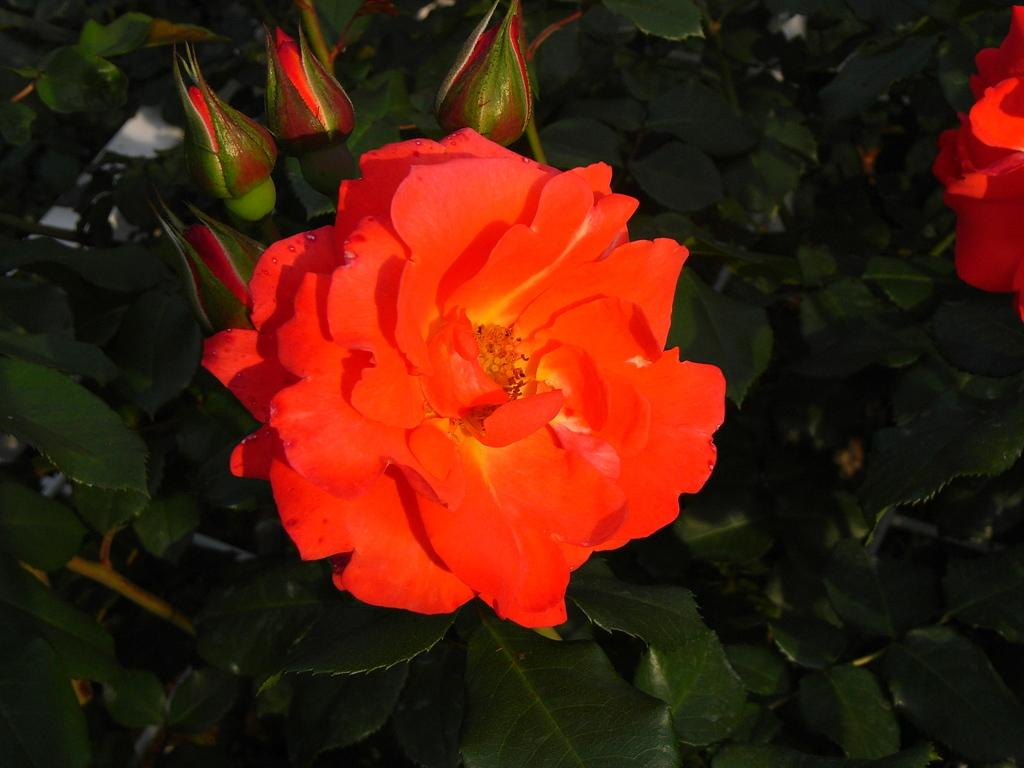What type of living organisms are present in the image? There is a group of plants in the image. Can you identify any specific flowers among the plants? Yes, there is a rose flower among the plants. What color is the rose flower? The rose flower is red in color. Are there any unopened flowers on the plants? Yes, there are flower buds on the plants. Can you tell me how many potatoes are hidden among the plants in the image? There are no potatoes present in the image; it features a group of plants with a red rose flower and flower buds. Is there a girl holding a wing in the image? There is no girl or wing present in the image. 